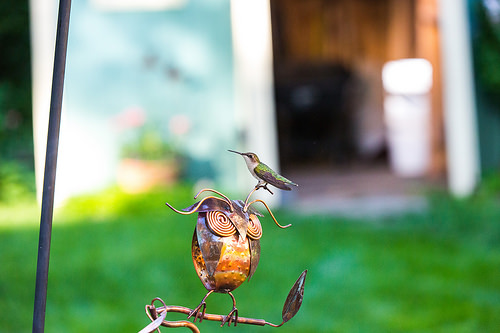<image>
Can you confirm if the hummingbird is above the owl? Yes. The hummingbird is positioned above the owl in the vertical space, higher up in the scene. 